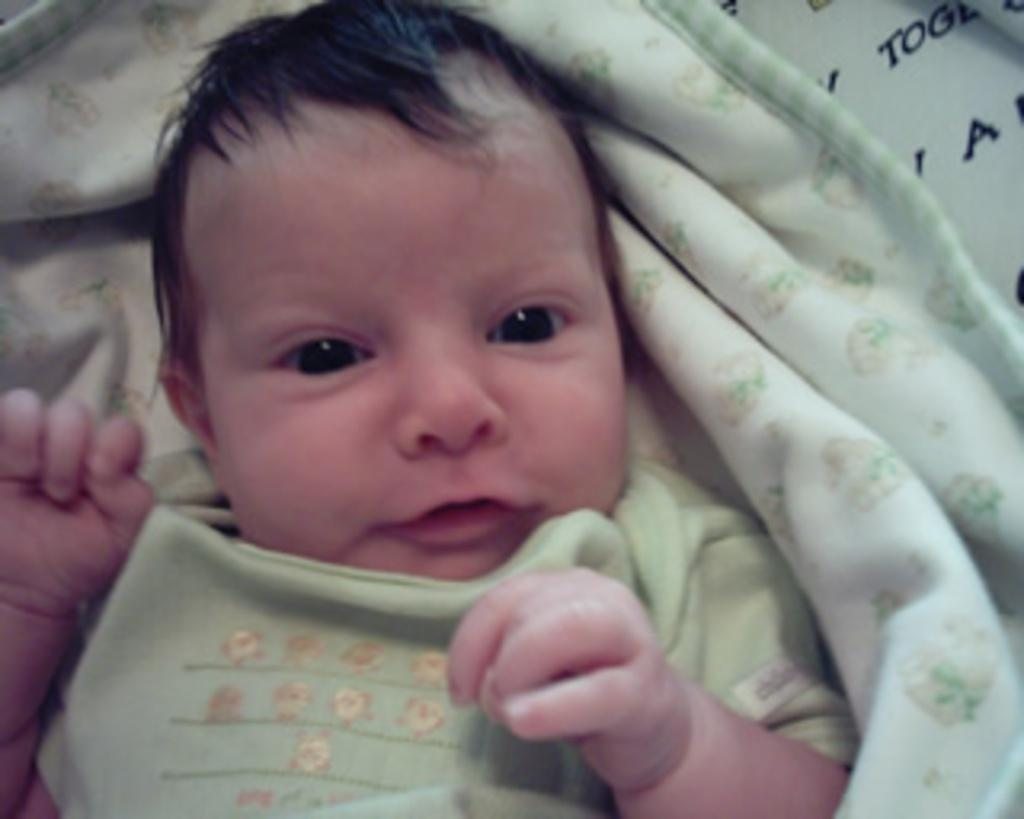What is the main subject of the image? There is a baby in the image. What is the baby lying on? The baby is lying on a cloth. What type of plough is the baby using in the image? There is no plough present in the image; it features a baby lying on a cloth. Who is the actor in the image? There is no actor present in the image; it features a baby lying on a cloth. 